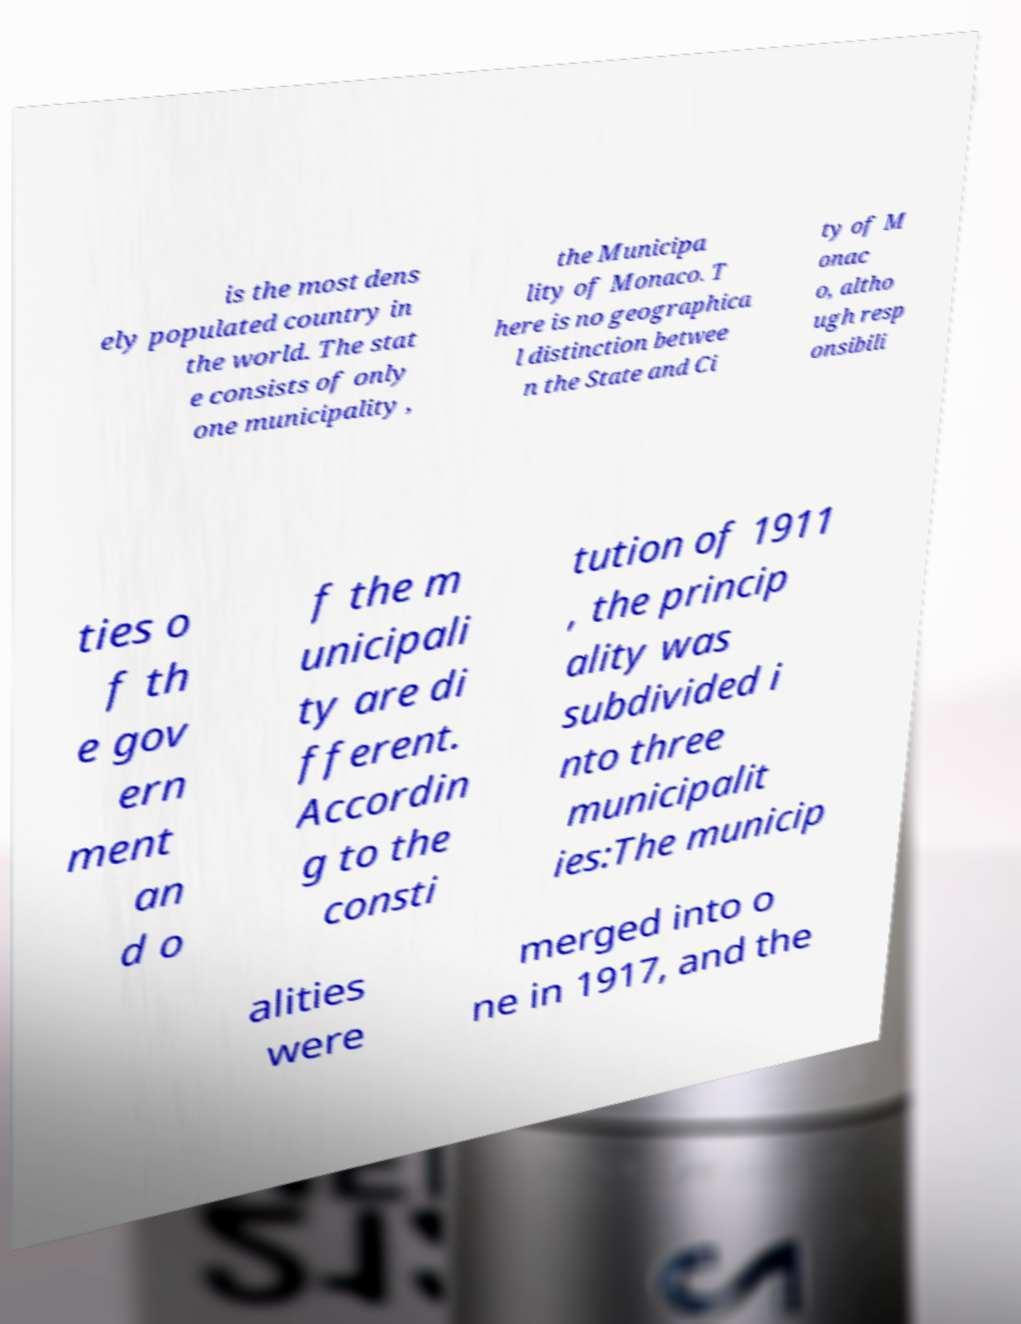What messages or text are displayed in this image? I need them in a readable, typed format. is the most dens ely populated country in the world. The stat e consists of only one municipality , the Municipa lity of Monaco. T here is no geographica l distinction betwee n the State and Ci ty of M onac o, altho ugh resp onsibili ties o f th e gov ern ment an d o f the m unicipali ty are di fferent. Accordin g to the consti tution of 1911 , the princip ality was subdivided i nto three municipalit ies:The municip alities were merged into o ne in 1917, and the 